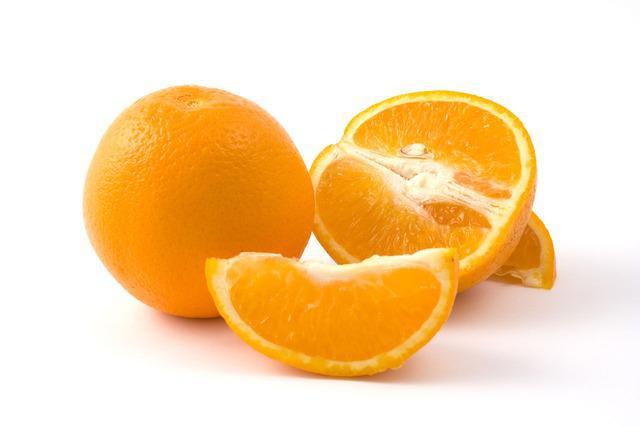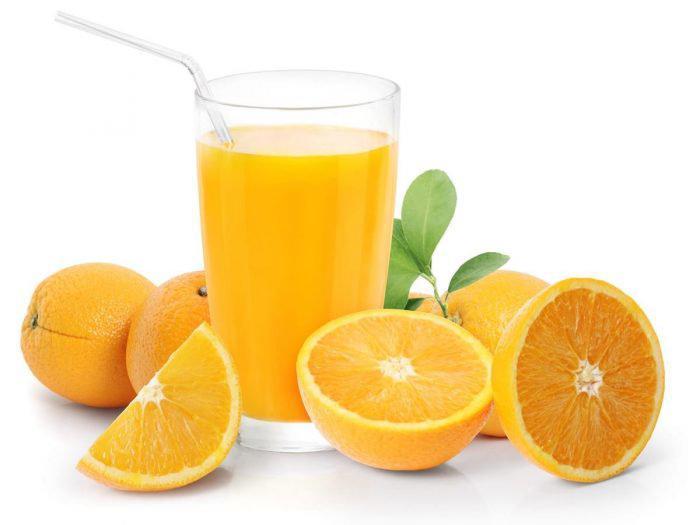The first image is the image on the left, the second image is the image on the right. Analyze the images presented: Is the assertion "Only one image contains the juice of the oranges." valid? Answer yes or no. Yes. The first image is the image on the left, the second image is the image on the right. Considering the images on both sides, is "Some of the oranges are cut into wedges, not just halves." valid? Answer yes or no. Yes. 